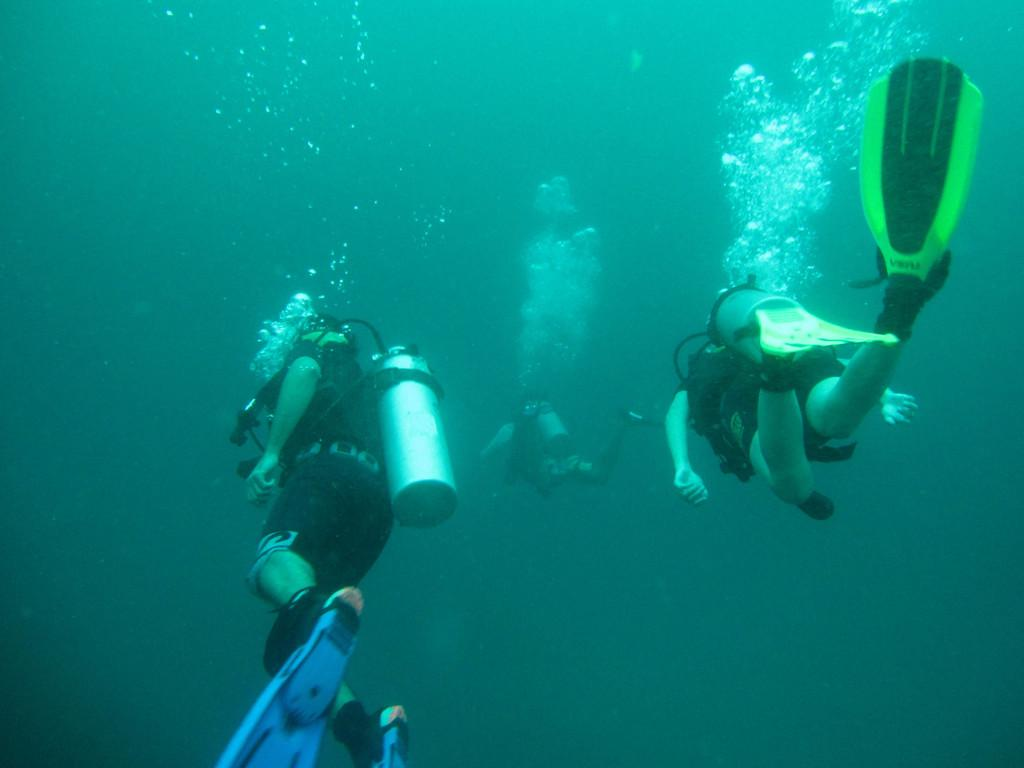Who are the subjects in the image? There are people in the image. What activity are the people engaged in? The people are doing scuba diving. What type of clothing are the people wearing? The people are wearing swimsuits. What equipment are the people carrying? The people are carrying cylinders of oxygen. What can be observed in the water around the people? There are water bubbles in the image. What type of jewel is the person holding in the image? There is no jewel visible in the image; the people are doing scuba diving and carrying cylinders of oxygen. How does the person maintain their grip on the equipment while underwater? The image does not show how the person maintains their grip on the equipment, but it can be assumed that they are using their hands and possibly straps or harnesses to secure the oxygen cylinders. 